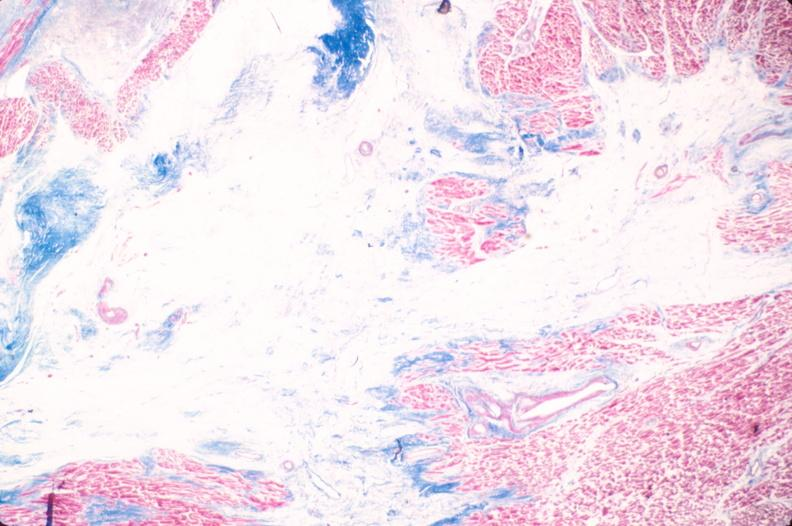s cardiovascular present?
Answer the question using a single word or phrase. Yes 